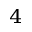Convert formula to latex. <formula><loc_0><loc_0><loc_500><loc_500>^ { 4 }</formula> 